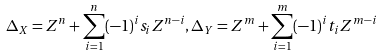<formula> <loc_0><loc_0><loc_500><loc_500>\Delta _ { X } = Z ^ { n } + \sum _ { i = 1 } ^ { n } ( - 1 ) ^ { i } s _ { i } Z ^ { n - i } , \Delta _ { Y } = Z ^ { m } + \sum _ { i = 1 } ^ { m } ( - 1 ) ^ { i } t _ { i } Z ^ { m - i }</formula> 